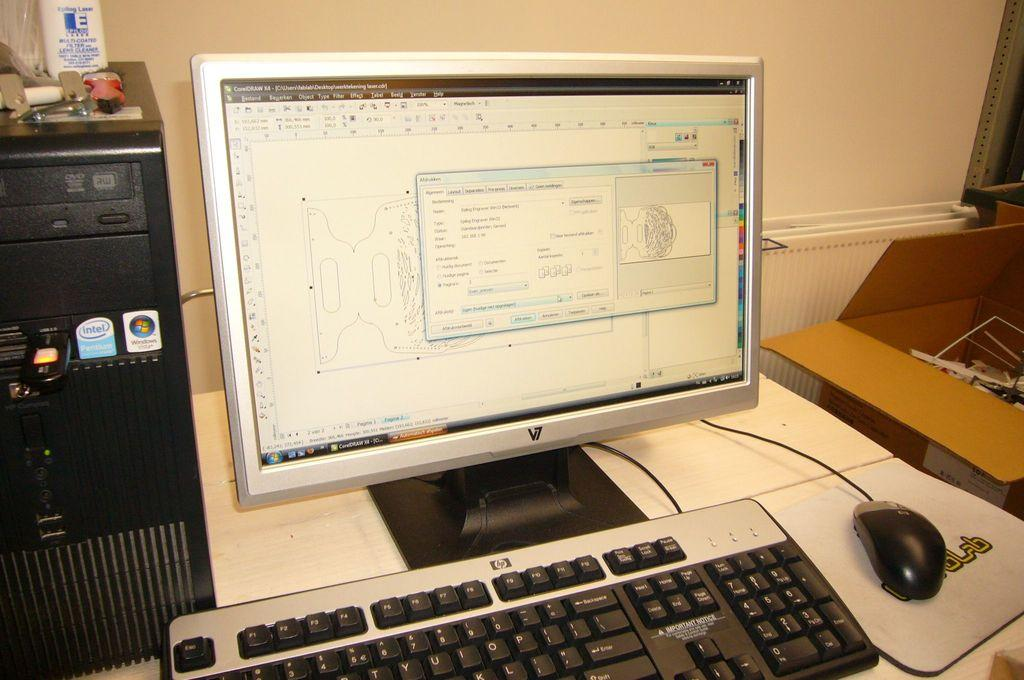<image>
Share a concise interpretation of the image provided. A CorelDRAW program is open on a computer screen. 